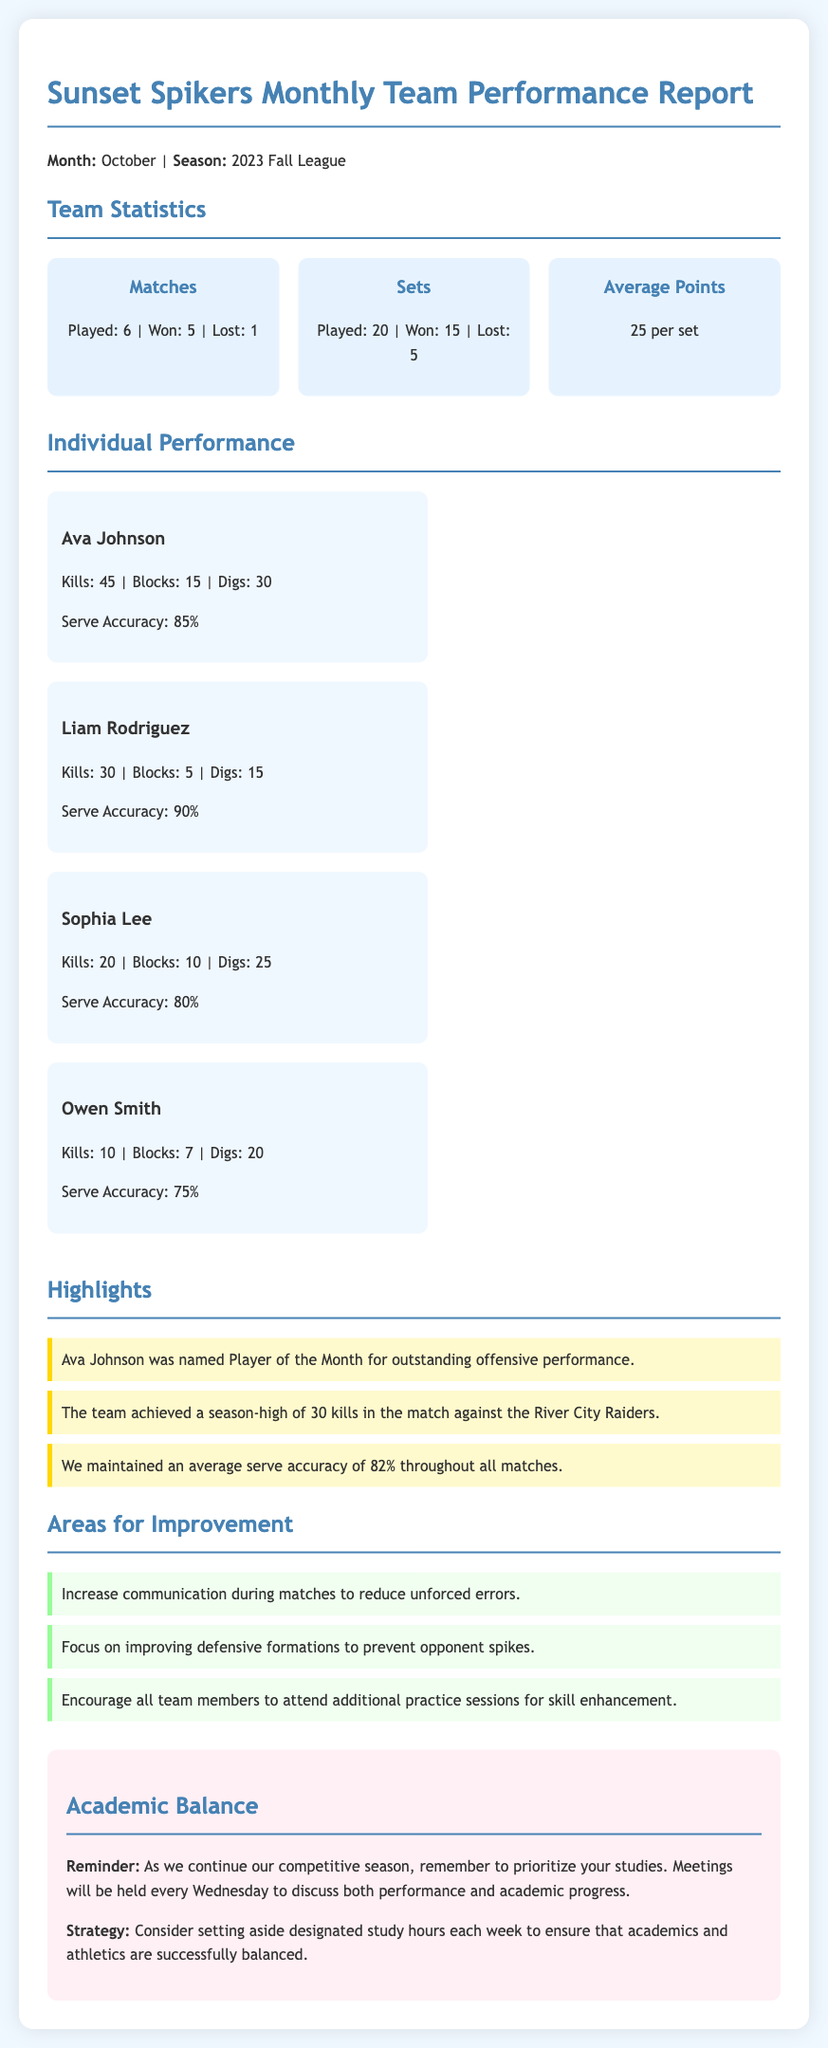What was the month of the report? The month of the report is stated in the opening paragraph of the document.
Answer: October How many matches did the team play? The total number of matches played is provided in the team statistics section.
Answer: 6 Who was named Player of the Month? The Player of the Month is mentioned in the highlights section of the document.
Answer: Ava Johnson What is the average serve accuracy of the team? The average serve accuracy is mentioned in the highlights section.
Answer: 82% What areas need improvement according to the report? Areas for improvement are listed in a specific section and summarized.
Answer: Communication, defensive formations, additional practice sessions How many kills did Ava Johnson score? Ava Johnson's kills are found in her individual performance card.
Answer: 45 What message is given about academic balance? The academic balance section includes a reminder for prioritizing studies and meetings.
Answer: Prioritize your studies How many sets did the team win? The number of sets won is mentioned in the team statistics section.
Answer: 15 What is the total number of blocks by Liam Rodriguez? Liam Rodriguez's blocks are stated in his individual performance card.
Answer: 5 